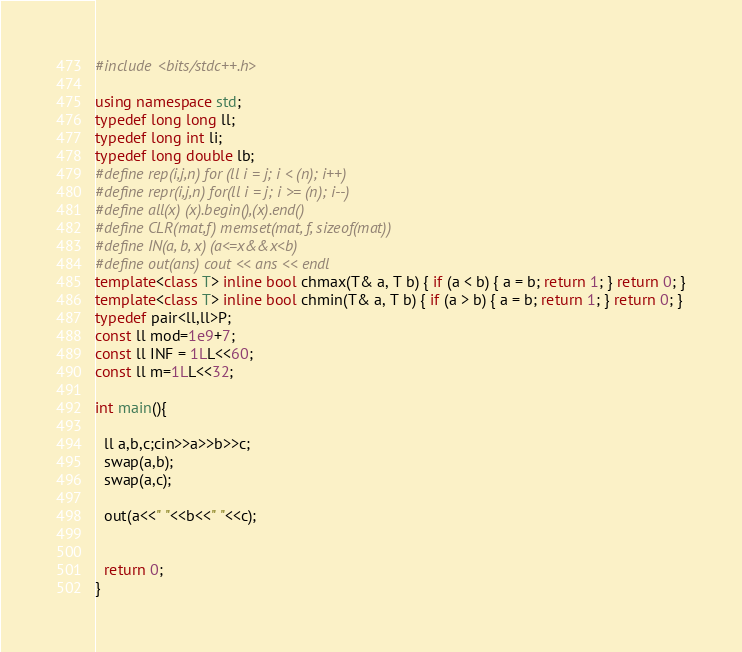Convert code to text. <code><loc_0><loc_0><loc_500><loc_500><_C++_>#include <bits/stdc++.h>

using namespace std;
typedef long long ll;
typedef long int li;
typedef long double lb;
#define rep(i,j,n) for (ll i = j; i < (n); i++)
#define repr(i,j,n) for(ll i = j; i >= (n); i--)
#define all(x) (x).begin(),(x).end()
#define CLR(mat,f) memset(mat, f, sizeof(mat))
#define IN(a, b, x) (a<=x&&x<b)
#define out(ans) cout << ans << endl
template<class T> inline bool chmax(T& a, T b) { if (a < b) { a = b; return 1; } return 0; }
template<class T> inline bool chmin(T& a, T b) { if (a > b) { a = b; return 1; } return 0; }
typedef pair<ll,ll>P;
const ll mod=1e9+7;
const ll INF = 1LL<<60;
const ll m=1LL<<32;

int main(){

  ll a,b,c;cin>>a>>b>>c;
  swap(a,b);
  swap(a,c);

  out(a<<" "<<b<<" "<<c);


  return 0;
}
</code> 